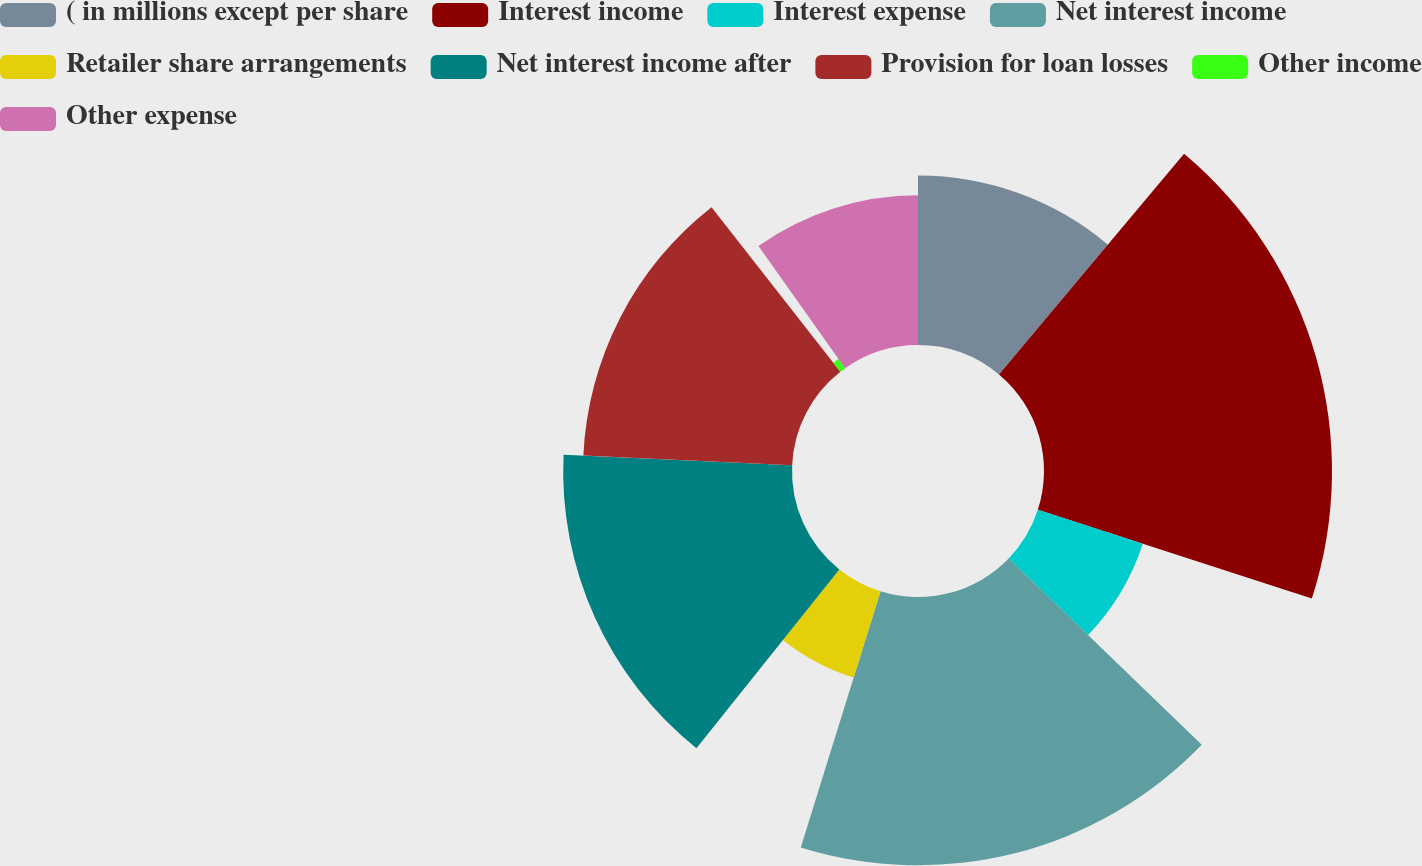Convert chart to OTSL. <chart><loc_0><loc_0><loc_500><loc_500><pie_chart><fcel>( in millions except per share<fcel>Interest income<fcel>Interest expense<fcel>Net interest income<fcel>Retailer share arrangements<fcel>Net interest income after<fcel>Provision for loan losses<fcel>Other income<fcel>Other expense<nl><fcel>11.11%<fcel>18.88%<fcel>7.23%<fcel>17.59%<fcel>5.93%<fcel>15.0%<fcel>13.7%<fcel>0.75%<fcel>9.82%<nl></chart> 